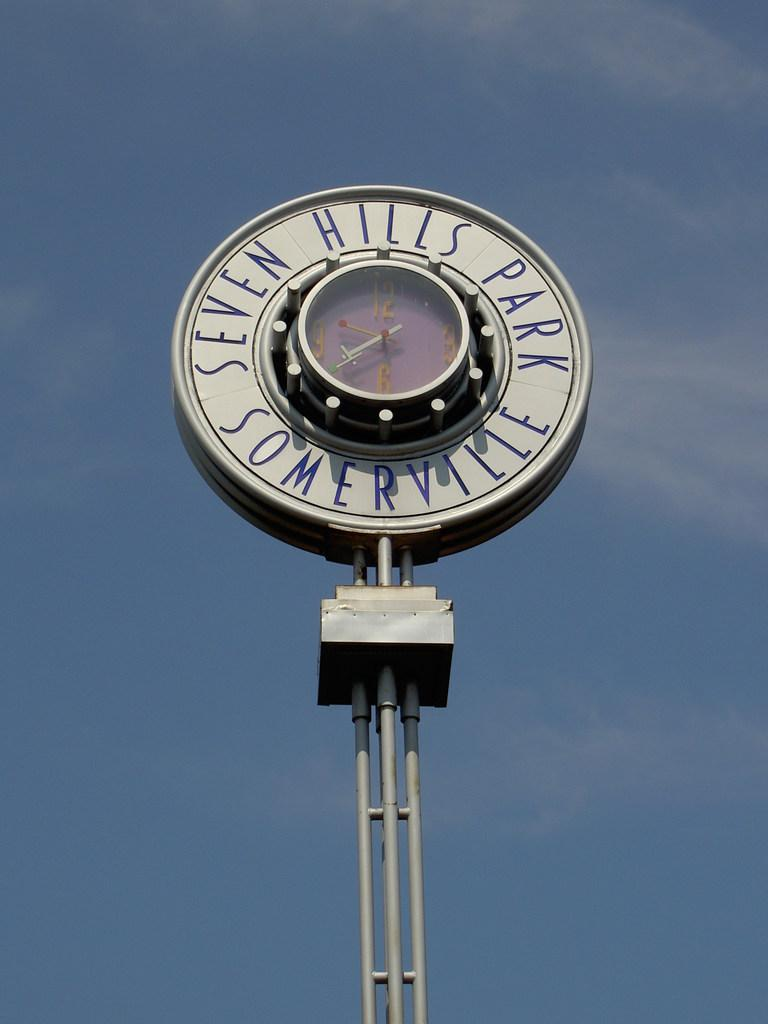What is located in the middle of the picture? There is a pole in the middle of the picture. What is attached to the pole? There is a clock on the pole. What information is displayed on the clock? The clock displays "SEVEN HILLS PARK SOMERVILLE". What can be seen in the background of the image? The sky is visible in the background of the image. What is the color of the sky in the image? The color of the sky is blue. How does the image address the issue of education in the community? The image does not address the issue of education; it primarily features a pole with a clock and the background sky. 